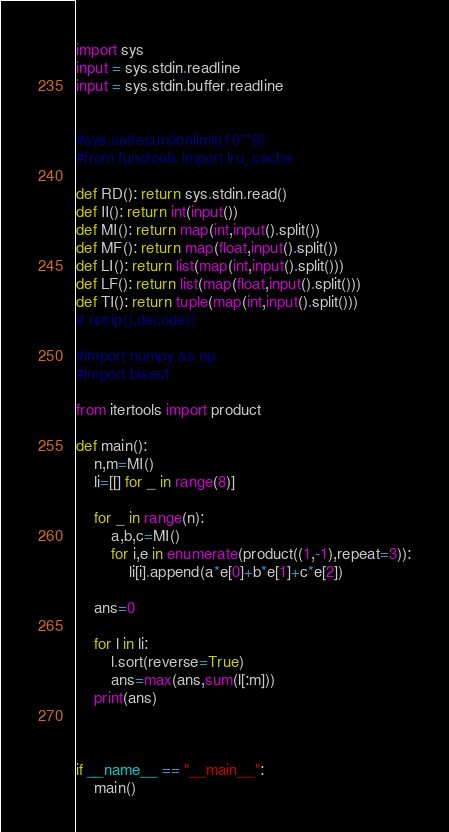Convert code to text. <code><loc_0><loc_0><loc_500><loc_500><_Python_>import sys
input = sys.stdin.readline
input = sys.stdin.buffer.readline


#sys.setrecursionlimit(10**9)
#from functools import lru_cache

def RD(): return sys.stdin.read()
def II(): return int(input())
def MI(): return map(int,input().split())
def MF(): return map(float,input().split())
def LI(): return list(map(int,input().split()))
def LF(): return list(map(float,input().split()))
def TI(): return tuple(map(int,input().split()))
# rstrip().decode()

#import numpy as np
#import bisect

from itertools import product

def main():
	n,m=MI()
	li=[[] for _ in range(8)]

	for _ in range(n):
		a,b,c=MI()
		for i,e in enumerate(product((1,-1),repeat=3)):
			li[i].append(a*e[0]+b*e[1]+c*e[2])

	ans=0

	for l in li:
		l.sort(reverse=True)
		ans=max(ans,sum(l[:m]))
	print(ans)



if __name__ == "__main__":
	main()
</code> 